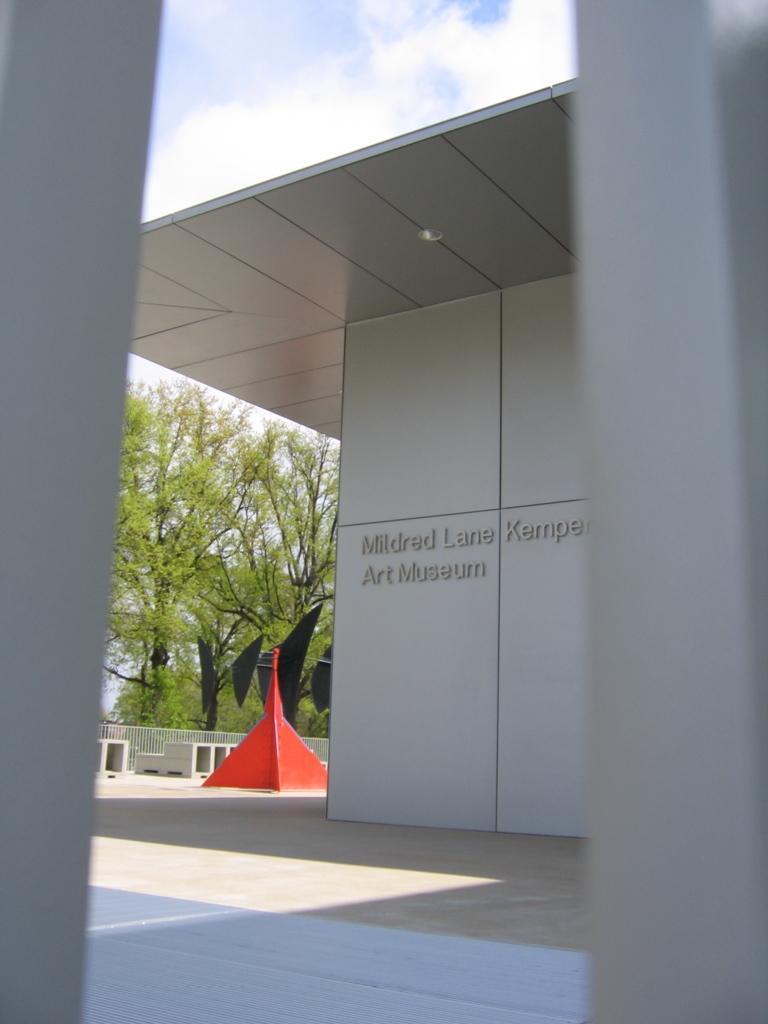In one or two sentences, can you explain what this image depicts? In this image we can see a building with name on the wall. In the back there is a red color object. In the background there is railing. Also there are trees and sky with clouds. 